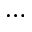Convert formula to latex. <formula><loc_0><loc_0><loc_500><loc_500>\cdots</formula> 